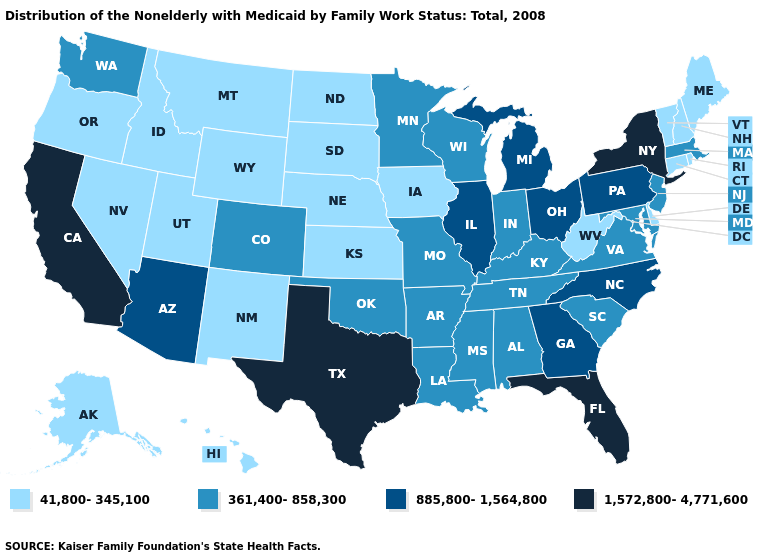What is the value of Missouri?
Answer briefly. 361,400-858,300. What is the value of Louisiana?
Concise answer only. 361,400-858,300. Which states hav the highest value in the MidWest?
Give a very brief answer. Illinois, Michigan, Ohio. What is the highest value in the Northeast ?
Answer briefly. 1,572,800-4,771,600. Does Pennsylvania have a higher value than Alabama?
Give a very brief answer. Yes. How many symbols are there in the legend?
Keep it brief. 4. Name the states that have a value in the range 361,400-858,300?
Concise answer only. Alabama, Arkansas, Colorado, Indiana, Kentucky, Louisiana, Maryland, Massachusetts, Minnesota, Mississippi, Missouri, New Jersey, Oklahoma, South Carolina, Tennessee, Virginia, Washington, Wisconsin. What is the lowest value in states that border California?
Be succinct. 41,800-345,100. Name the states that have a value in the range 885,800-1,564,800?
Keep it brief. Arizona, Georgia, Illinois, Michigan, North Carolina, Ohio, Pennsylvania. Name the states that have a value in the range 41,800-345,100?
Concise answer only. Alaska, Connecticut, Delaware, Hawaii, Idaho, Iowa, Kansas, Maine, Montana, Nebraska, Nevada, New Hampshire, New Mexico, North Dakota, Oregon, Rhode Island, South Dakota, Utah, Vermont, West Virginia, Wyoming. What is the value of Mississippi?
Keep it brief. 361,400-858,300. Name the states that have a value in the range 885,800-1,564,800?
Quick response, please. Arizona, Georgia, Illinois, Michigan, North Carolina, Ohio, Pennsylvania. What is the lowest value in the MidWest?
Concise answer only. 41,800-345,100. What is the highest value in the MidWest ?
Keep it brief. 885,800-1,564,800. What is the highest value in states that border Iowa?
Concise answer only. 885,800-1,564,800. 